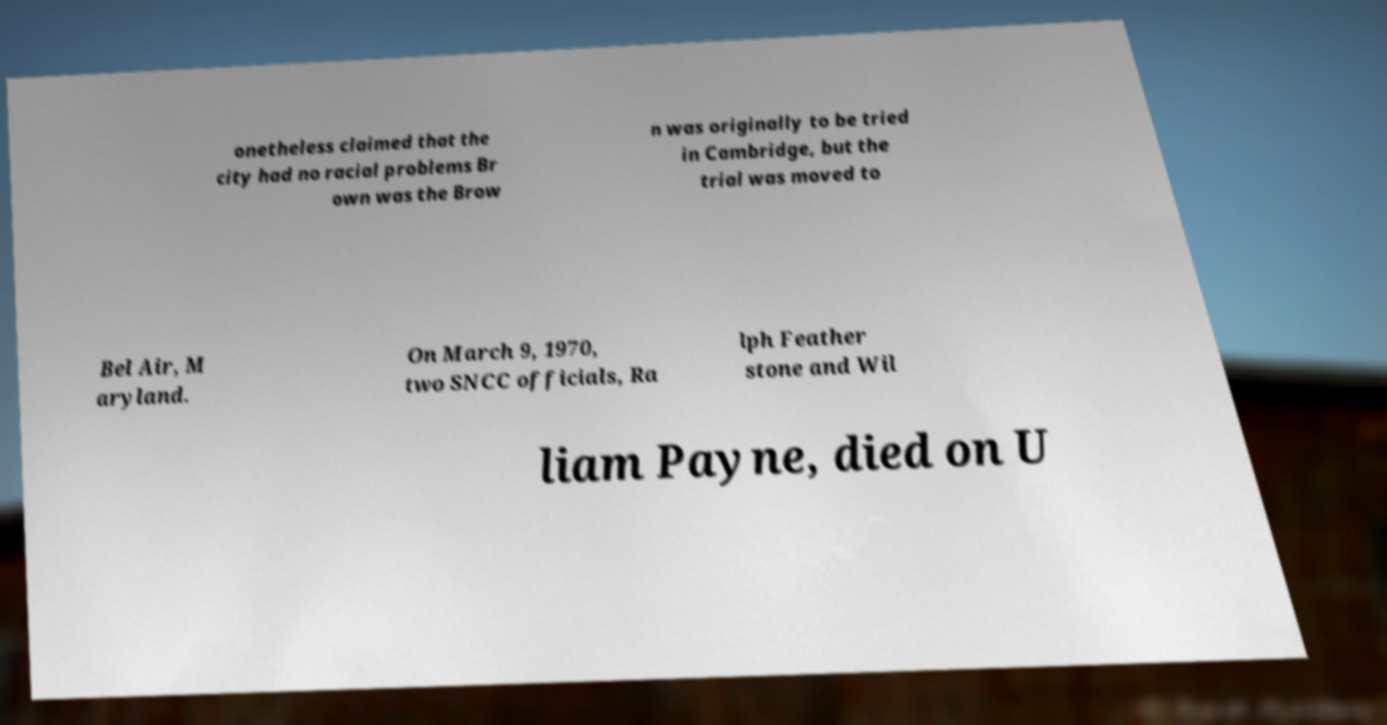What messages or text are displayed in this image? I need them in a readable, typed format. onetheless claimed that the city had no racial problems Br own was the Brow n was originally to be tried in Cambridge, but the trial was moved to Bel Air, M aryland. On March 9, 1970, two SNCC officials, Ra lph Feather stone and Wil liam Payne, died on U 